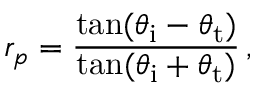Convert formula to latex. <formula><loc_0><loc_0><loc_500><loc_500>r _ { p } = { \frac { \tan ( \theta _ { i } - \theta _ { t } ) } { \tan ( \theta _ { i } + \theta _ { t } ) } } \, ,</formula> 